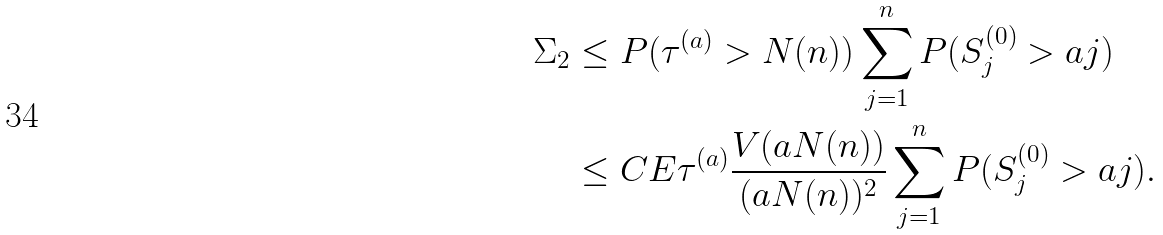<formula> <loc_0><loc_0><loc_500><loc_500>\Sigma _ { 2 } & \leq P ( \tau ^ { ( a ) } > N ( n ) ) \sum _ { j = 1 } ^ { n } P ( S _ { j } ^ { ( 0 ) } > a j ) \\ & \leq C E \tau ^ { ( a ) } \frac { V ( a N ( n ) ) } { ( a N ( n ) ) ^ { 2 } } \sum _ { j = 1 } ^ { n } P ( S _ { j } ^ { ( 0 ) } > a j ) .</formula> 